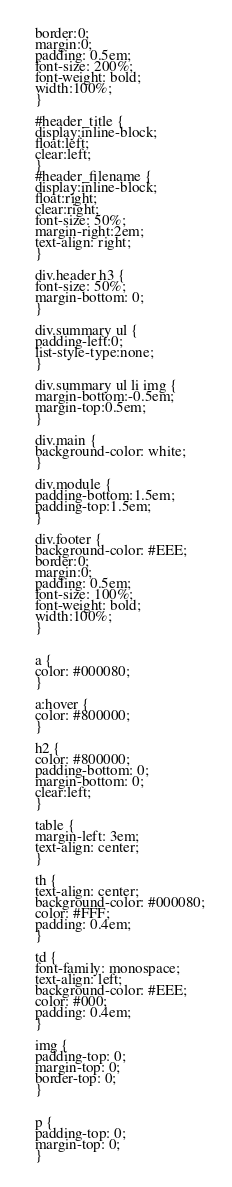Convert code to text. <code><loc_0><loc_0><loc_500><loc_500><_HTML_>  border:0;
  margin:0;
  padding: 0.5em;
  font-size: 200%;
  font-weight: bold;
  width:100%;
  }    
  
  #header_title {
  display:inline-block;
  float:left;
  clear:left;
  }
  #header_filename {
  display:inline-block;
  float:right;
  clear:right;
  font-size: 50%;
  margin-right:2em;
  text-align: right;
  }

  div.header h3 {
  font-size: 50%;
  margin-bottom: 0;
  }
  
  div.summary ul {
  padding-left:0;
  list-style-type:none;
  }
  
  div.summary ul li img {
  margin-bottom:-0.5em;
  margin-top:0.5em;
  }
	  
  div.main {
  background-color: white;
  }
      
  div.module {
  padding-bottom:1.5em;
  padding-top:1.5em;
  }
	  
  div.footer {
  background-color: #EEE;
  border:0;
  margin:0;
  padding: 0.5em;
  font-size: 100%;
  font-weight: bold;
  width:100%;
  }


  a {
  color: #000080;
  }

  a:hover {
  color: #800000;
  }
      
  h2 {
  color: #800000;
  padding-bottom: 0;
  margin-bottom: 0;
  clear:left;
  }

  table { 
  margin-left: 3em;
  text-align: center;
  }
  
  th { 
  text-align: center;
  background-color: #000080;
  color: #FFF;
  padding: 0.4em;
  }      
  
  td { 
  font-family: monospace; 
  text-align: left;
  background-color: #EEE;
  color: #000;
  padding: 0.4em;
  }

  img {
  padding-top: 0;
  margin-top: 0;
  border-top: 0;
  }

  
  p {
  padding-top: 0;
  margin-top: 0;
  }</code> 